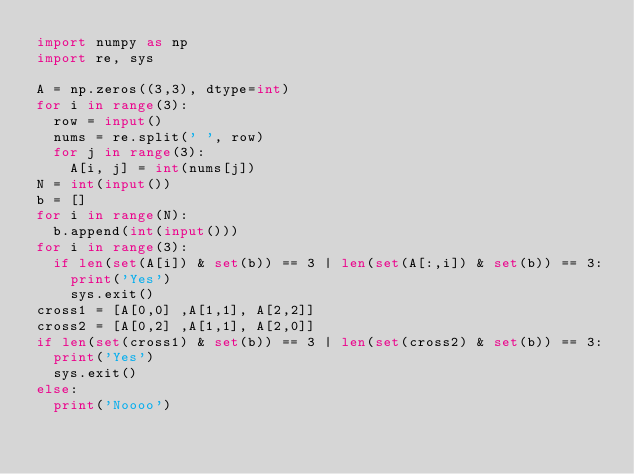<code> <loc_0><loc_0><loc_500><loc_500><_Python_>import numpy as np
import re, sys

A = np.zeros((3,3), dtype=int)
for i in range(3):
  row = input()
  nums = re.split(' ', row)
  for j in range(3):
  	A[i, j] = int(nums[j])
N = int(input())
b = []
for i in range(N):
  b.append(int(input()))
for i in range(3):
  if len(set(A[i]) & set(b)) == 3 | len(set(A[:,i]) & set(b)) == 3:
    print('Yes')
    sys.exit()
cross1 = [A[0,0] ,A[1,1], A[2,2]]
cross2 = [A[0,2] ,A[1,1], A[2,0]]
if len(set(cross1) & set(b)) == 3 | len(set(cross2) & set(b)) == 3:
  print('Yes')
  sys.exit()
else:
  print('Noooo')</code> 